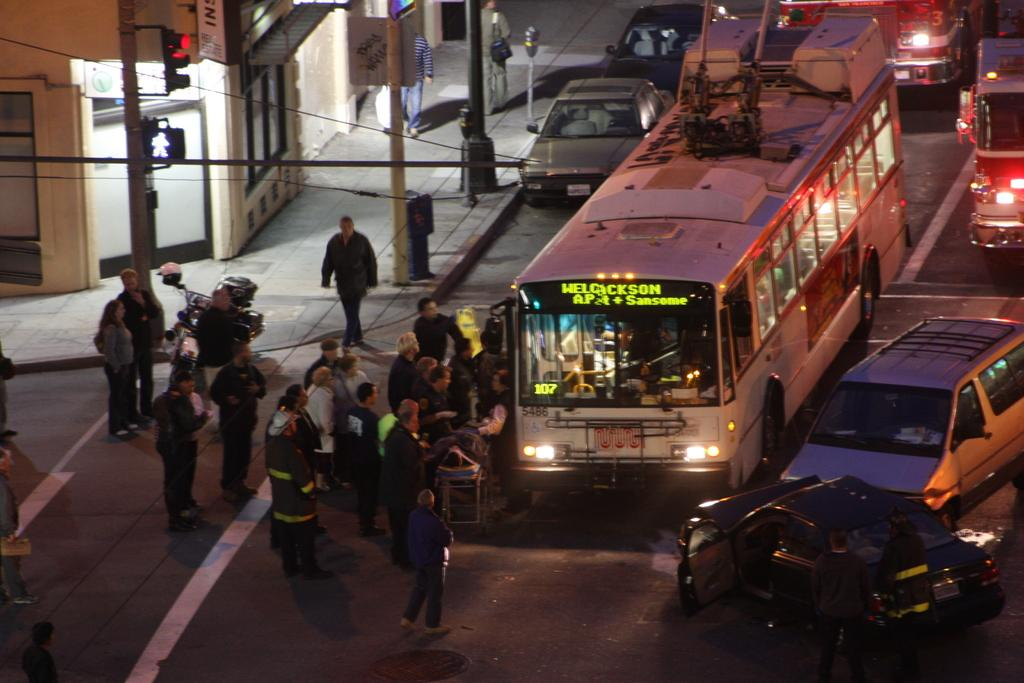What can be seen on the road in the image? There are vehicles on the road in the image. What structures are present in the image? There are poles, lights, and a building in the image. Who or what is visible in the image? There are people in the image. What architectural features can be seen in the image? There are windows and doors in the image. What type of signage is present in the image? There are boards with text in the image. What animal can be seen running across the road in the image? There is no animal running across the road in the image. What is the purpose of the lights in the image? The purpose of the lights in the image cannot be determined from the image alone. 